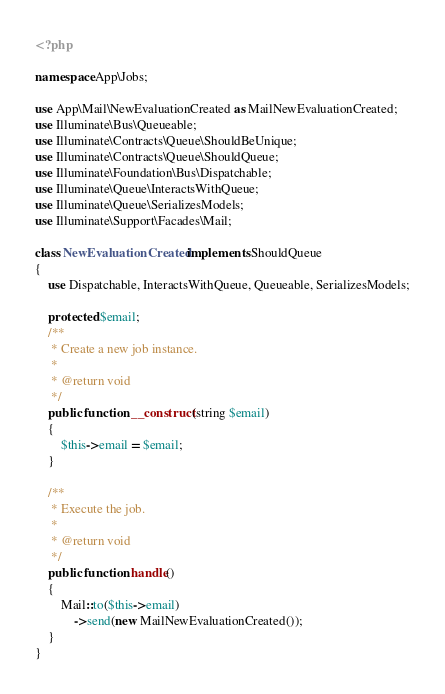Convert code to text. <code><loc_0><loc_0><loc_500><loc_500><_PHP_><?php

namespace App\Jobs;

use App\Mail\NewEvaluationCreated as MailNewEvaluationCreated;
use Illuminate\Bus\Queueable;
use Illuminate\Contracts\Queue\ShouldBeUnique;
use Illuminate\Contracts\Queue\ShouldQueue;
use Illuminate\Foundation\Bus\Dispatchable;
use Illuminate\Queue\InteractsWithQueue;
use Illuminate\Queue\SerializesModels;
use Illuminate\Support\Facades\Mail;

class NewEvaluationCreated implements ShouldQueue
{
    use Dispatchable, InteractsWithQueue, Queueable, SerializesModels;

    protected $email;
    /**
     * Create a new job instance.
     *
     * @return void
     */
    public function __construct(string $email)
    {
        $this->email = $email;
    }

    /**
     * Execute the job.
     *
     * @return void
     */
    public function handle()
    {
        Mail::to($this->email)
            ->send(new MailNewEvaluationCreated());
    }
}
</code> 